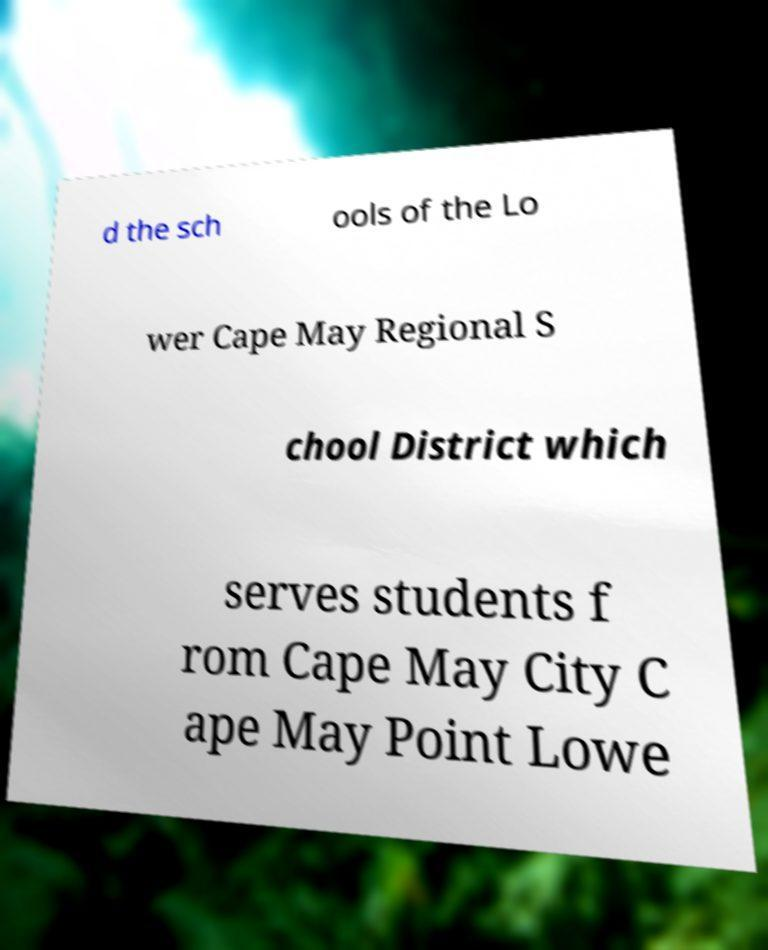There's text embedded in this image that I need extracted. Can you transcribe it verbatim? d the sch ools of the Lo wer Cape May Regional S chool District which serves students f rom Cape May City C ape May Point Lowe 